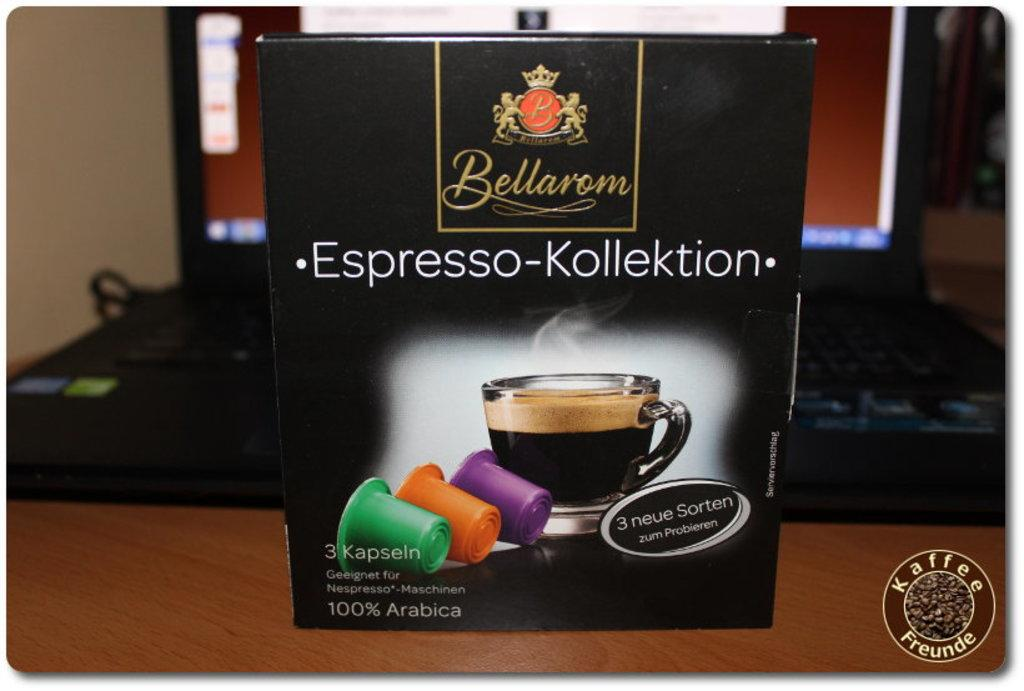What object is the main focus of the image? There is a box in the image. Can you describe any other objects visible in the image? In the background of the image, there is a laptop. How many cats are sitting on the box in the image? There are no cats present in the image; it only features a box and a laptop in the background. 